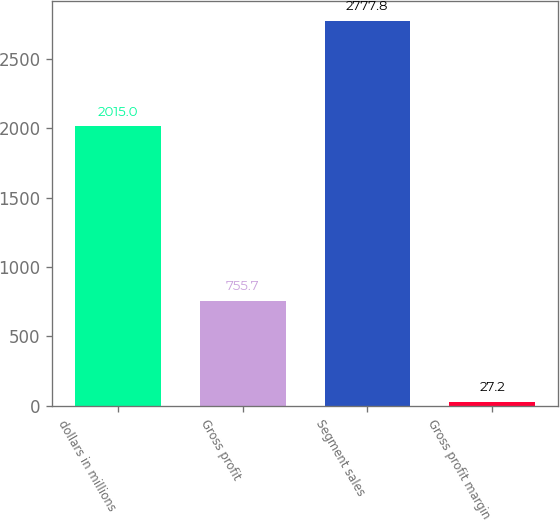<chart> <loc_0><loc_0><loc_500><loc_500><bar_chart><fcel>dollars in millions<fcel>Gross profit<fcel>Segment sales<fcel>Gross profit margin<nl><fcel>2015<fcel>755.7<fcel>2777.8<fcel>27.2<nl></chart> 